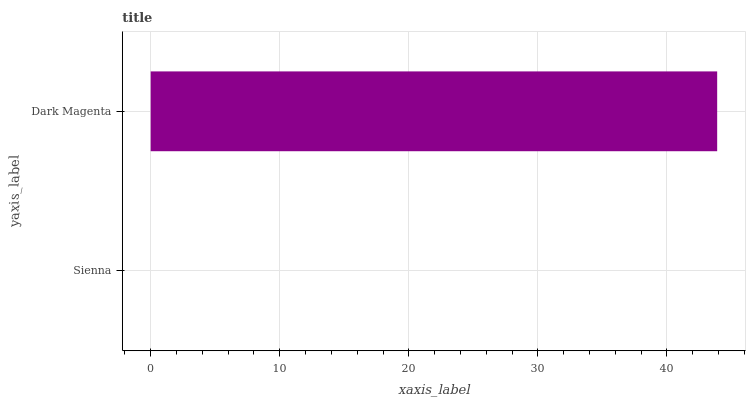Is Sienna the minimum?
Answer yes or no. Yes. Is Dark Magenta the maximum?
Answer yes or no. Yes. Is Dark Magenta the minimum?
Answer yes or no. No. Is Dark Magenta greater than Sienna?
Answer yes or no. Yes. Is Sienna less than Dark Magenta?
Answer yes or no. Yes. Is Sienna greater than Dark Magenta?
Answer yes or no. No. Is Dark Magenta less than Sienna?
Answer yes or no. No. Is Dark Magenta the high median?
Answer yes or no. Yes. Is Sienna the low median?
Answer yes or no. Yes. Is Sienna the high median?
Answer yes or no. No. Is Dark Magenta the low median?
Answer yes or no. No. 